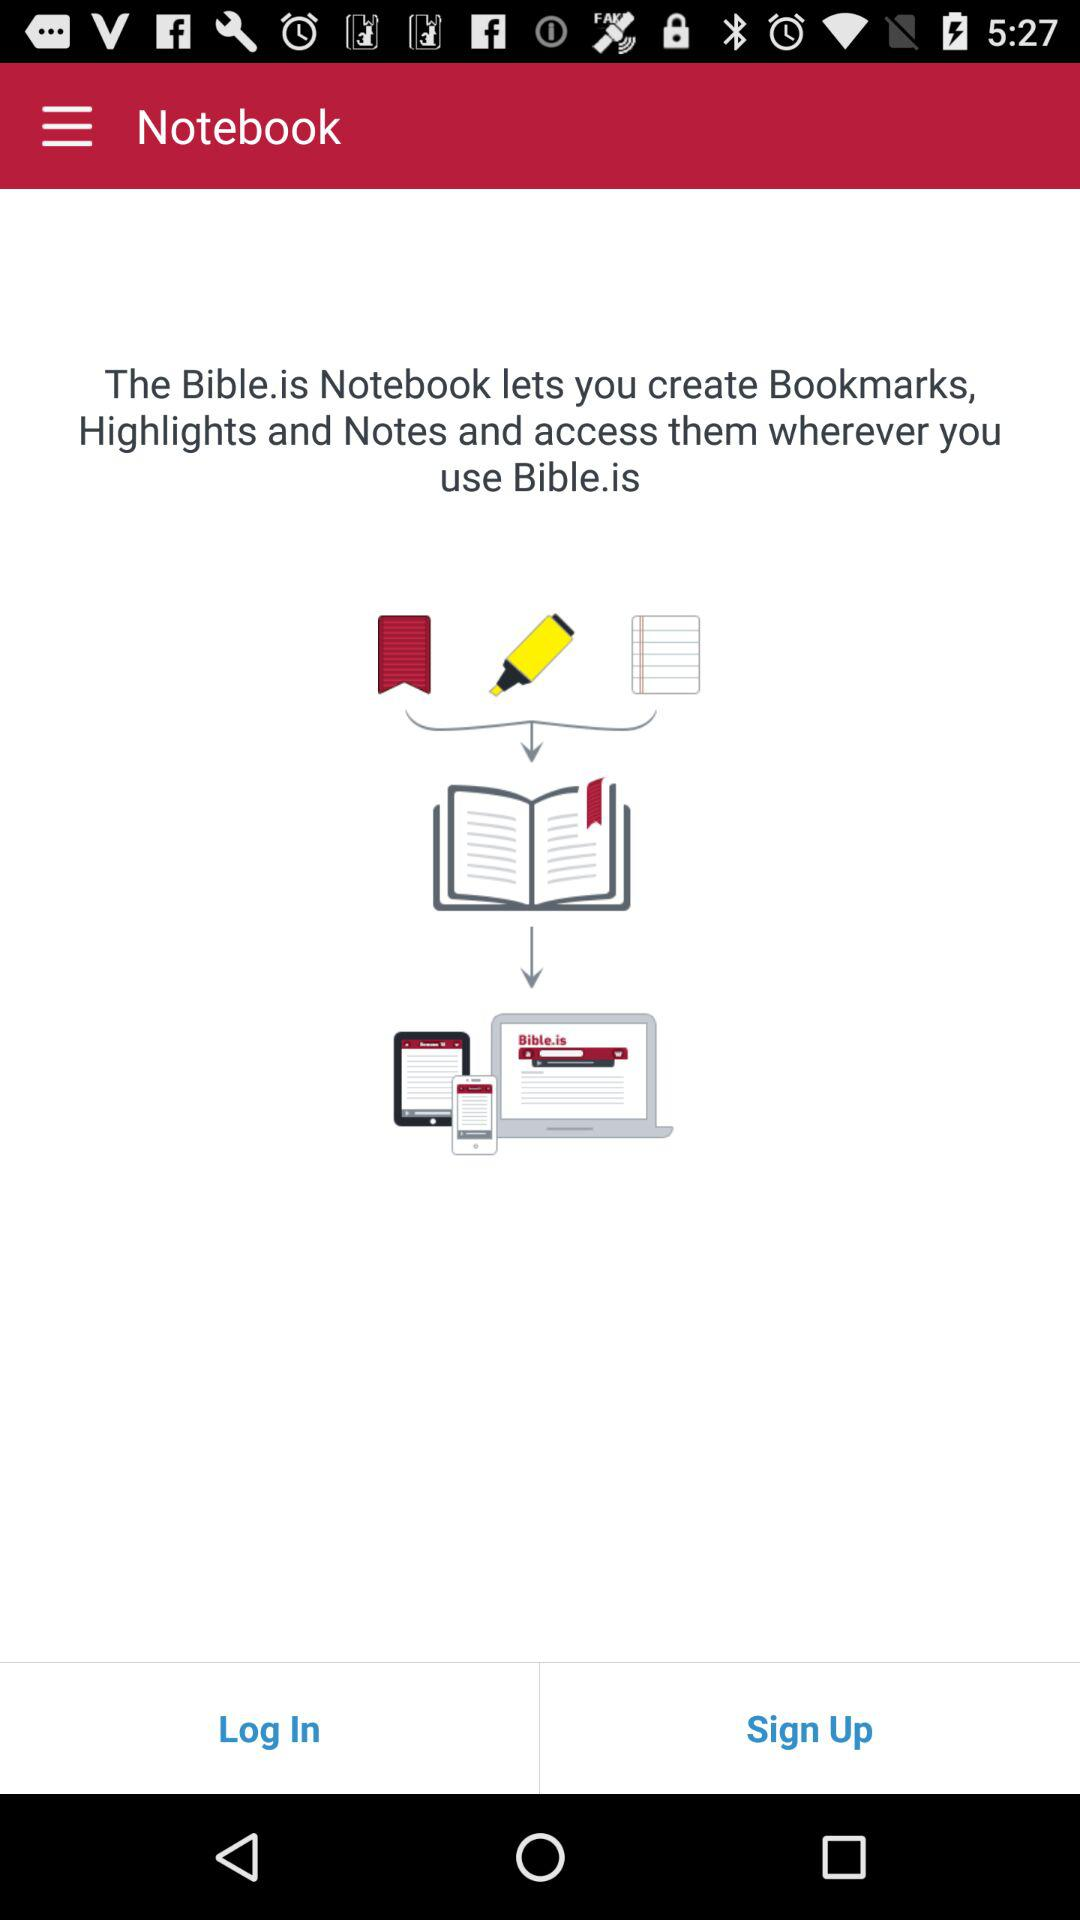What is the application name? The application name is "Bible.is". 